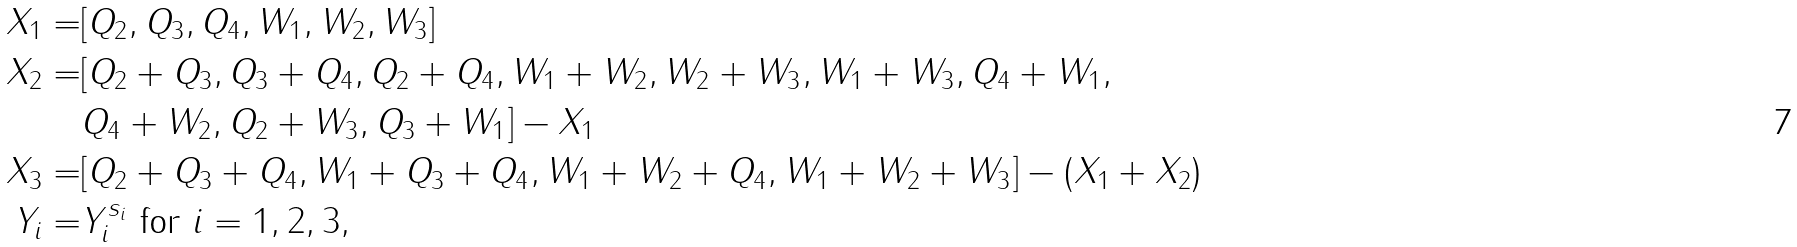<formula> <loc_0><loc_0><loc_500><loc_500>X _ { 1 } = & [ Q _ { 2 } , Q _ { 3 } , Q _ { 4 } , W _ { 1 } , W _ { 2 } , W _ { 3 } ] \\ X _ { 2 } = & [ Q _ { 2 } + Q _ { 3 } , Q _ { 3 } + Q _ { 4 } , Q _ { 2 } + Q _ { 4 } , W _ { 1 } + W _ { 2 } , W _ { 2 } + W _ { 3 } , W _ { 1 } + W _ { 3 } , Q _ { 4 } + W _ { 1 } , \\ & Q _ { 4 } + W _ { 2 } , Q _ { 2 } + W _ { 3 } , Q _ { 3 } + W _ { 1 } ] - X _ { 1 } \\ X _ { 3 } = & [ Q _ { 2 } + Q _ { 3 } + Q _ { 4 } , W _ { 1 } + Q _ { 3 } + Q _ { 4 } , W _ { 1 } + W _ { 2 } + Q _ { 4 } , W _ { 1 } + W _ { 2 } + W _ { 3 } ] - ( X _ { 1 } + X _ { 2 } ) \\ Y _ { i } = & Y _ { i } ^ { s _ { i } } \text { for $i=1,2,3$} ,</formula> 